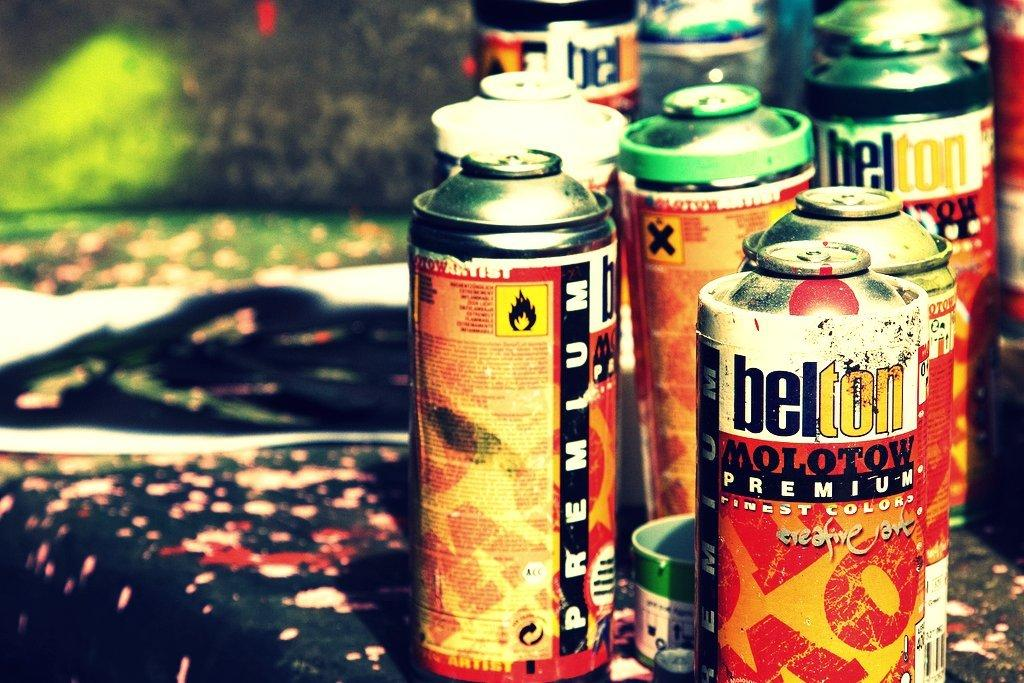<image>
Summarize the visual content of the image. Several belton molotow premium spray paint cans sitting on a messy table. 